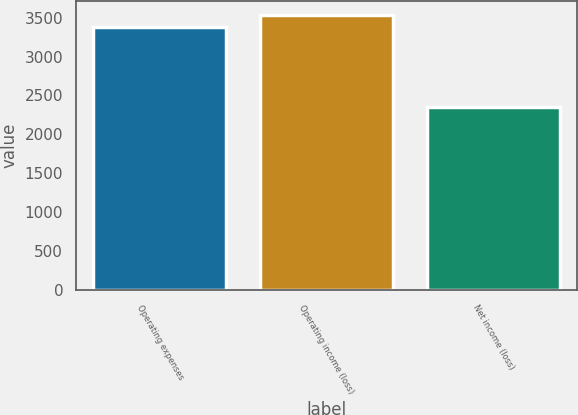Convert chart. <chart><loc_0><loc_0><loc_500><loc_500><bar_chart><fcel>Operating expenses<fcel>Operating income (loss)<fcel>Net income (loss)<nl><fcel>3373<fcel>3538<fcel>2353<nl></chart> 